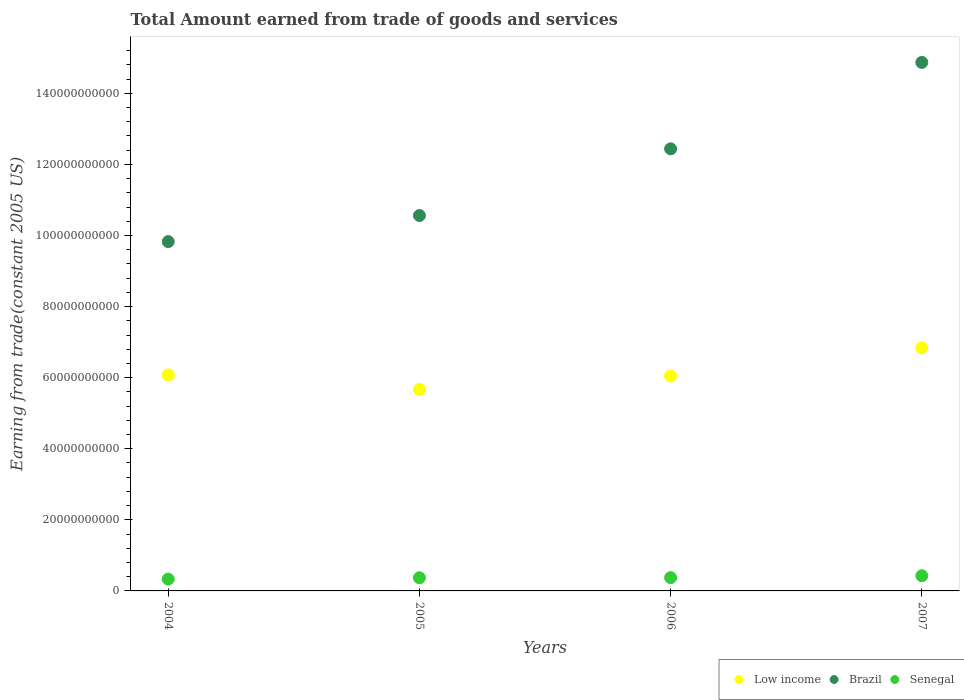Is the number of dotlines equal to the number of legend labels?
Offer a very short reply. Yes. What is the total amount earned by trading goods and services in Low income in 2007?
Offer a very short reply. 6.84e+1. Across all years, what is the maximum total amount earned by trading goods and services in Senegal?
Your response must be concise. 4.27e+09. Across all years, what is the minimum total amount earned by trading goods and services in Brazil?
Your answer should be compact. 9.83e+1. In which year was the total amount earned by trading goods and services in Brazil maximum?
Provide a succinct answer. 2007. What is the total total amount earned by trading goods and services in Brazil in the graph?
Give a very brief answer. 4.77e+11. What is the difference between the total amount earned by trading goods and services in Brazil in 2004 and that in 2007?
Keep it short and to the point. -5.04e+1. What is the difference between the total amount earned by trading goods and services in Low income in 2005 and the total amount earned by trading goods and services in Brazil in 2007?
Your answer should be very brief. -9.20e+1. What is the average total amount earned by trading goods and services in Low income per year?
Your response must be concise. 6.16e+1. In the year 2005, what is the difference between the total amount earned by trading goods and services in Low income and total amount earned by trading goods and services in Brazil?
Your answer should be very brief. -4.89e+1. In how many years, is the total amount earned by trading goods and services in Low income greater than 116000000000 US$?
Ensure brevity in your answer.  0. What is the ratio of the total amount earned by trading goods and services in Low income in 2005 to that in 2007?
Provide a succinct answer. 0.83. Is the total amount earned by trading goods and services in Low income in 2004 less than that in 2007?
Provide a succinct answer. Yes. Is the difference between the total amount earned by trading goods and services in Low income in 2004 and 2005 greater than the difference between the total amount earned by trading goods and services in Brazil in 2004 and 2005?
Keep it short and to the point. Yes. What is the difference between the highest and the second highest total amount earned by trading goods and services in Low income?
Your answer should be very brief. 7.64e+09. What is the difference between the highest and the lowest total amount earned by trading goods and services in Senegal?
Make the answer very short. 9.46e+08. In how many years, is the total amount earned by trading goods and services in Brazil greater than the average total amount earned by trading goods and services in Brazil taken over all years?
Give a very brief answer. 2. Does the total amount earned by trading goods and services in Senegal monotonically increase over the years?
Offer a terse response. Yes. Is the total amount earned by trading goods and services in Low income strictly greater than the total amount earned by trading goods and services in Senegal over the years?
Your answer should be compact. Yes. Is the total amount earned by trading goods and services in Low income strictly less than the total amount earned by trading goods and services in Senegal over the years?
Your response must be concise. No. How many years are there in the graph?
Provide a short and direct response. 4. What is the difference between two consecutive major ticks on the Y-axis?
Ensure brevity in your answer.  2.00e+1. Are the values on the major ticks of Y-axis written in scientific E-notation?
Provide a short and direct response. No. Does the graph contain grids?
Give a very brief answer. No. What is the title of the graph?
Your response must be concise. Total Amount earned from trade of goods and services. What is the label or title of the Y-axis?
Ensure brevity in your answer.  Earning from trade(constant 2005 US). What is the Earning from trade(constant 2005 US) in Low income in 2004?
Provide a succinct answer. 6.08e+1. What is the Earning from trade(constant 2005 US) of Brazil in 2004?
Your answer should be compact. 9.83e+1. What is the Earning from trade(constant 2005 US) in Senegal in 2004?
Ensure brevity in your answer.  3.33e+09. What is the Earning from trade(constant 2005 US) of Low income in 2005?
Offer a terse response. 5.67e+1. What is the Earning from trade(constant 2005 US) of Brazil in 2005?
Give a very brief answer. 1.06e+11. What is the Earning from trade(constant 2005 US) in Senegal in 2005?
Keep it short and to the point. 3.69e+09. What is the Earning from trade(constant 2005 US) of Low income in 2006?
Offer a terse response. 6.05e+1. What is the Earning from trade(constant 2005 US) of Brazil in 2006?
Your answer should be compact. 1.24e+11. What is the Earning from trade(constant 2005 US) of Senegal in 2006?
Ensure brevity in your answer.  3.74e+09. What is the Earning from trade(constant 2005 US) in Low income in 2007?
Provide a succinct answer. 6.84e+1. What is the Earning from trade(constant 2005 US) of Brazil in 2007?
Ensure brevity in your answer.  1.49e+11. What is the Earning from trade(constant 2005 US) in Senegal in 2007?
Offer a very short reply. 4.27e+09. Across all years, what is the maximum Earning from trade(constant 2005 US) in Low income?
Provide a short and direct response. 6.84e+1. Across all years, what is the maximum Earning from trade(constant 2005 US) of Brazil?
Keep it short and to the point. 1.49e+11. Across all years, what is the maximum Earning from trade(constant 2005 US) of Senegal?
Offer a very short reply. 4.27e+09. Across all years, what is the minimum Earning from trade(constant 2005 US) of Low income?
Your answer should be very brief. 5.67e+1. Across all years, what is the minimum Earning from trade(constant 2005 US) of Brazil?
Provide a short and direct response. 9.83e+1. Across all years, what is the minimum Earning from trade(constant 2005 US) in Senegal?
Offer a very short reply. 3.33e+09. What is the total Earning from trade(constant 2005 US) in Low income in the graph?
Offer a very short reply. 2.46e+11. What is the total Earning from trade(constant 2005 US) of Brazil in the graph?
Keep it short and to the point. 4.77e+11. What is the total Earning from trade(constant 2005 US) of Senegal in the graph?
Provide a succinct answer. 1.50e+1. What is the difference between the Earning from trade(constant 2005 US) of Low income in 2004 and that in 2005?
Your answer should be compact. 4.08e+09. What is the difference between the Earning from trade(constant 2005 US) in Brazil in 2004 and that in 2005?
Your answer should be very brief. -7.34e+09. What is the difference between the Earning from trade(constant 2005 US) of Senegal in 2004 and that in 2005?
Make the answer very short. -3.68e+08. What is the difference between the Earning from trade(constant 2005 US) in Low income in 2004 and that in 2006?
Give a very brief answer. 2.92e+08. What is the difference between the Earning from trade(constant 2005 US) in Brazil in 2004 and that in 2006?
Provide a succinct answer. -2.61e+1. What is the difference between the Earning from trade(constant 2005 US) of Senegal in 2004 and that in 2006?
Your answer should be very brief. -4.12e+08. What is the difference between the Earning from trade(constant 2005 US) in Low income in 2004 and that in 2007?
Keep it short and to the point. -7.64e+09. What is the difference between the Earning from trade(constant 2005 US) of Brazil in 2004 and that in 2007?
Give a very brief answer. -5.04e+1. What is the difference between the Earning from trade(constant 2005 US) in Senegal in 2004 and that in 2007?
Keep it short and to the point. -9.46e+08. What is the difference between the Earning from trade(constant 2005 US) of Low income in 2005 and that in 2006?
Offer a very short reply. -3.79e+09. What is the difference between the Earning from trade(constant 2005 US) of Brazil in 2005 and that in 2006?
Your answer should be compact. -1.88e+1. What is the difference between the Earning from trade(constant 2005 US) of Senegal in 2005 and that in 2006?
Offer a very short reply. -4.41e+07. What is the difference between the Earning from trade(constant 2005 US) of Low income in 2005 and that in 2007?
Make the answer very short. -1.17e+1. What is the difference between the Earning from trade(constant 2005 US) of Brazil in 2005 and that in 2007?
Your response must be concise. -4.31e+1. What is the difference between the Earning from trade(constant 2005 US) of Senegal in 2005 and that in 2007?
Keep it short and to the point. -5.78e+08. What is the difference between the Earning from trade(constant 2005 US) of Low income in 2006 and that in 2007?
Your response must be concise. -7.93e+09. What is the difference between the Earning from trade(constant 2005 US) of Brazil in 2006 and that in 2007?
Give a very brief answer. -2.43e+1. What is the difference between the Earning from trade(constant 2005 US) of Senegal in 2006 and that in 2007?
Provide a short and direct response. -5.34e+08. What is the difference between the Earning from trade(constant 2005 US) in Low income in 2004 and the Earning from trade(constant 2005 US) in Brazil in 2005?
Give a very brief answer. -4.49e+1. What is the difference between the Earning from trade(constant 2005 US) of Low income in 2004 and the Earning from trade(constant 2005 US) of Senegal in 2005?
Offer a terse response. 5.71e+1. What is the difference between the Earning from trade(constant 2005 US) in Brazil in 2004 and the Earning from trade(constant 2005 US) in Senegal in 2005?
Your answer should be compact. 9.46e+1. What is the difference between the Earning from trade(constant 2005 US) in Low income in 2004 and the Earning from trade(constant 2005 US) in Brazil in 2006?
Offer a very short reply. -6.36e+1. What is the difference between the Earning from trade(constant 2005 US) of Low income in 2004 and the Earning from trade(constant 2005 US) of Senegal in 2006?
Your answer should be very brief. 5.70e+1. What is the difference between the Earning from trade(constant 2005 US) in Brazil in 2004 and the Earning from trade(constant 2005 US) in Senegal in 2006?
Your answer should be very brief. 9.45e+1. What is the difference between the Earning from trade(constant 2005 US) of Low income in 2004 and the Earning from trade(constant 2005 US) of Brazil in 2007?
Your answer should be very brief. -8.79e+1. What is the difference between the Earning from trade(constant 2005 US) in Low income in 2004 and the Earning from trade(constant 2005 US) in Senegal in 2007?
Make the answer very short. 5.65e+1. What is the difference between the Earning from trade(constant 2005 US) in Brazil in 2004 and the Earning from trade(constant 2005 US) in Senegal in 2007?
Provide a short and direct response. 9.40e+1. What is the difference between the Earning from trade(constant 2005 US) in Low income in 2005 and the Earning from trade(constant 2005 US) in Brazil in 2006?
Offer a very short reply. -6.77e+1. What is the difference between the Earning from trade(constant 2005 US) of Low income in 2005 and the Earning from trade(constant 2005 US) of Senegal in 2006?
Provide a short and direct response. 5.29e+1. What is the difference between the Earning from trade(constant 2005 US) in Brazil in 2005 and the Earning from trade(constant 2005 US) in Senegal in 2006?
Give a very brief answer. 1.02e+11. What is the difference between the Earning from trade(constant 2005 US) in Low income in 2005 and the Earning from trade(constant 2005 US) in Brazil in 2007?
Provide a short and direct response. -9.20e+1. What is the difference between the Earning from trade(constant 2005 US) of Low income in 2005 and the Earning from trade(constant 2005 US) of Senegal in 2007?
Provide a succinct answer. 5.24e+1. What is the difference between the Earning from trade(constant 2005 US) in Brazil in 2005 and the Earning from trade(constant 2005 US) in Senegal in 2007?
Your answer should be very brief. 1.01e+11. What is the difference between the Earning from trade(constant 2005 US) of Low income in 2006 and the Earning from trade(constant 2005 US) of Brazil in 2007?
Provide a short and direct response. -8.82e+1. What is the difference between the Earning from trade(constant 2005 US) in Low income in 2006 and the Earning from trade(constant 2005 US) in Senegal in 2007?
Provide a succinct answer. 5.62e+1. What is the difference between the Earning from trade(constant 2005 US) in Brazil in 2006 and the Earning from trade(constant 2005 US) in Senegal in 2007?
Provide a succinct answer. 1.20e+11. What is the average Earning from trade(constant 2005 US) of Low income per year?
Your answer should be compact. 6.16e+1. What is the average Earning from trade(constant 2005 US) in Brazil per year?
Provide a short and direct response. 1.19e+11. What is the average Earning from trade(constant 2005 US) of Senegal per year?
Make the answer very short. 3.76e+09. In the year 2004, what is the difference between the Earning from trade(constant 2005 US) of Low income and Earning from trade(constant 2005 US) of Brazil?
Give a very brief answer. -3.75e+1. In the year 2004, what is the difference between the Earning from trade(constant 2005 US) in Low income and Earning from trade(constant 2005 US) in Senegal?
Provide a short and direct response. 5.74e+1. In the year 2004, what is the difference between the Earning from trade(constant 2005 US) in Brazil and Earning from trade(constant 2005 US) in Senegal?
Provide a short and direct response. 9.50e+1. In the year 2005, what is the difference between the Earning from trade(constant 2005 US) of Low income and Earning from trade(constant 2005 US) of Brazil?
Give a very brief answer. -4.89e+1. In the year 2005, what is the difference between the Earning from trade(constant 2005 US) of Low income and Earning from trade(constant 2005 US) of Senegal?
Provide a succinct answer. 5.30e+1. In the year 2005, what is the difference between the Earning from trade(constant 2005 US) of Brazil and Earning from trade(constant 2005 US) of Senegal?
Your response must be concise. 1.02e+11. In the year 2006, what is the difference between the Earning from trade(constant 2005 US) in Low income and Earning from trade(constant 2005 US) in Brazil?
Your answer should be very brief. -6.39e+1. In the year 2006, what is the difference between the Earning from trade(constant 2005 US) of Low income and Earning from trade(constant 2005 US) of Senegal?
Make the answer very short. 5.67e+1. In the year 2006, what is the difference between the Earning from trade(constant 2005 US) in Brazil and Earning from trade(constant 2005 US) in Senegal?
Your response must be concise. 1.21e+11. In the year 2007, what is the difference between the Earning from trade(constant 2005 US) in Low income and Earning from trade(constant 2005 US) in Brazil?
Make the answer very short. -8.03e+1. In the year 2007, what is the difference between the Earning from trade(constant 2005 US) in Low income and Earning from trade(constant 2005 US) in Senegal?
Give a very brief answer. 6.41e+1. In the year 2007, what is the difference between the Earning from trade(constant 2005 US) in Brazil and Earning from trade(constant 2005 US) in Senegal?
Provide a succinct answer. 1.44e+11. What is the ratio of the Earning from trade(constant 2005 US) in Low income in 2004 to that in 2005?
Your answer should be compact. 1.07. What is the ratio of the Earning from trade(constant 2005 US) of Brazil in 2004 to that in 2005?
Your answer should be very brief. 0.93. What is the ratio of the Earning from trade(constant 2005 US) of Senegal in 2004 to that in 2005?
Keep it short and to the point. 0.9. What is the ratio of the Earning from trade(constant 2005 US) of Low income in 2004 to that in 2006?
Your answer should be very brief. 1. What is the ratio of the Earning from trade(constant 2005 US) in Brazil in 2004 to that in 2006?
Offer a terse response. 0.79. What is the ratio of the Earning from trade(constant 2005 US) in Senegal in 2004 to that in 2006?
Provide a succinct answer. 0.89. What is the ratio of the Earning from trade(constant 2005 US) in Low income in 2004 to that in 2007?
Your answer should be compact. 0.89. What is the ratio of the Earning from trade(constant 2005 US) of Brazil in 2004 to that in 2007?
Provide a short and direct response. 0.66. What is the ratio of the Earning from trade(constant 2005 US) of Senegal in 2004 to that in 2007?
Make the answer very short. 0.78. What is the ratio of the Earning from trade(constant 2005 US) in Low income in 2005 to that in 2006?
Give a very brief answer. 0.94. What is the ratio of the Earning from trade(constant 2005 US) of Brazil in 2005 to that in 2006?
Your answer should be compact. 0.85. What is the ratio of the Earning from trade(constant 2005 US) of Low income in 2005 to that in 2007?
Your answer should be very brief. 0.83. What is the ratio of the Earning from trade(constant 2005 US) of Brazil in 2005 to that in 2007?
Keep it short and to the point. 0.71. What is the ratio of the Earning from trade(constant 2005 US) of Senegal in 2005 to that in 2007?
Keep it short and to the point. 0.86. What is the ratio of the Earning from trade(constant 2005 US) in Low income in 2006 to that in 2007?
Offer a very short reply. 0.88. What is the ratio of the Earning from trade(constant 2005 US) in Brazil in 2006 to that in 2007?
Ensure brevity in your answer.  0.84. What is the difference between the highest and the second highest Earning from trade(constant 2005 US) in Low income?
Ensure brevity in your answer.  7.64e+09. What is the difference between the highest and the second highest Earning from trade(constant 2005 US) of Brazil?
Offer a terse response. 2.43e+1. What is the difference between the highest and the second highest Earning from trade(constant 2005 US) of Senegal?
Make the answer very short. 5.34e+08. What is the difference between the highest and the lowest Earning from trade(constant 2005 US) of Low income?
Provide a short and direct response. 1.17e+1. What is the difference between the highest and the lowest Earning from trade(constant 2005 US) of Brazil?
Offer a very short reply. 5.04e+1. What is the difference between the highest and the lowest Earning from trade(constant 2005 US) of Senegal?
Provide a succinct answer. 9.46e+08. 